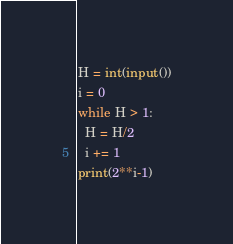<code> <loc_0><loc_0><loc_500><loc_500><_Python_>H = int(input())
i = 0
while H > 1:
  H = H/2
  i += 1
print(2**i-1)
</code> 